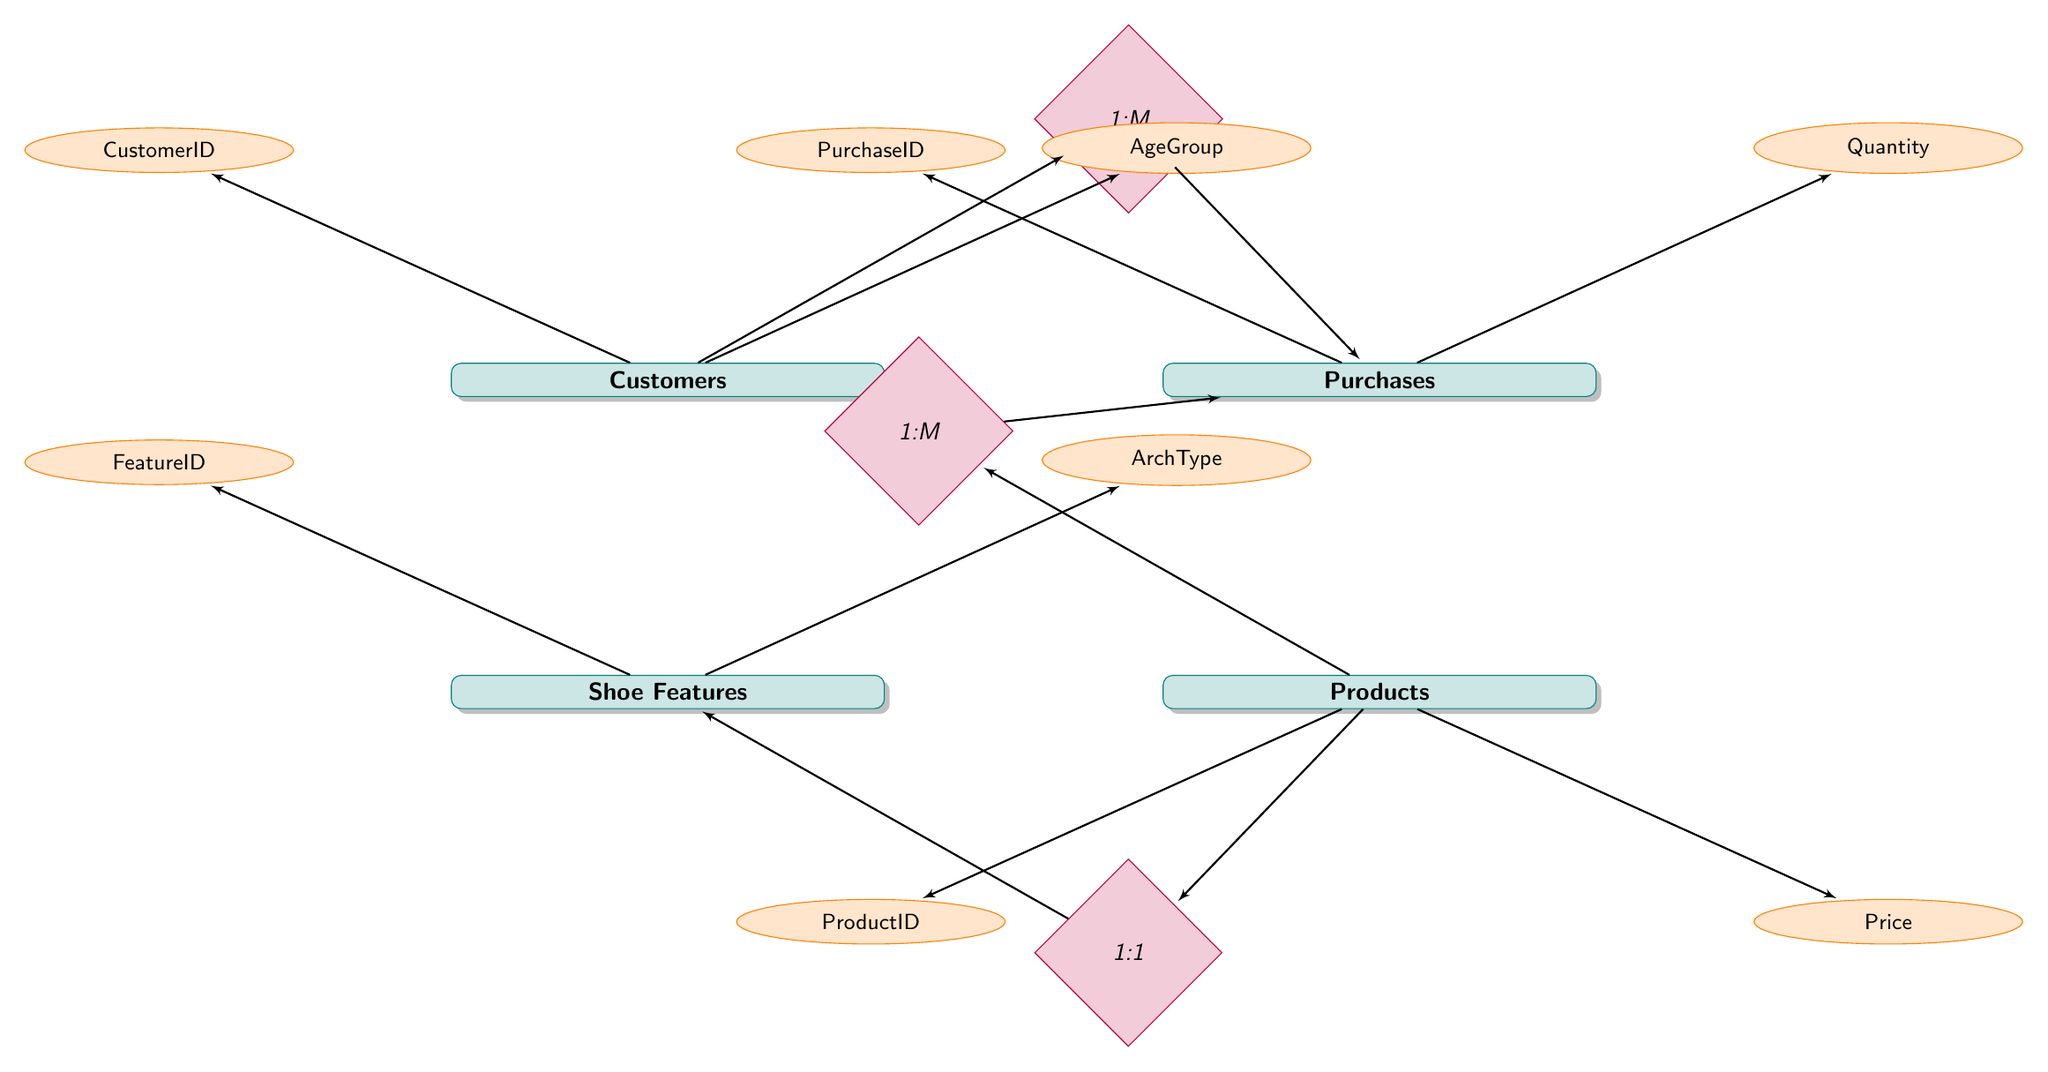What are the attributes of the Customers entity? The Customers entity includes the attributes CustomerID, AgeGroup, Gender, GeographicalRegion, and IncomeLevel, as represented in the diagram.
Answer: CustomerID, AgeGroup, Gender, GeographicalRegion, IncomeLevel How many entities are present in this diagram? The diagram includes four entities: Customers, Purchases, Products, and Shoe Features. Therefore, the count of entities is four.
Answer: 4 What is the relationship type between Products and Purchases? The diagram shows a '1 to Many' relationship from Products to Purchases, indicating that one product can have many purchases associated with it.
Answer: 1 to Many Which attribute belongs to the Purchases entity? The Purchasing entity contains multiple attributes, including PurchaseID, Quantity, and TotalAmount. For this response, we can take one: PurchaseID, as it clearly represents a distinct identifier.
Answer: PurchaseID How many Shoe Features are associated with each Product? According to the diagram, there is a '1 to 1' relationship between Products and Shoe Features, suggesting that each product is associated with exactly one shoe feature entry.
Answer: 1 Which entity has a '1 to Many' relationship with Purchases? The diagram clearly states that the Customers entity has a '1 to Many' relationship with Purchases, which indicates that a single customer can have multiple purchases.
Answer: Customers What is the Foreign Key in the Customer_Purchases relationship? In the Customer_Purchases relationship, the Foreign Key is CustomerID, which is used to connect the Customers entity to the Purchases entity.
Answer: CustomerID What is an attribute of the Shoe Features entity? One of the attributes in the Shoe Features entity is ArchType, which distinguishes the type of arch support offered in shoes.
Answer: ArchType Which entity is connected to the Product_Purchases relationship? The Products entity is directly connected to the Product_Purchases relationship, signifying that each product can be purchased multiple times by different customers.
Answer: Products 